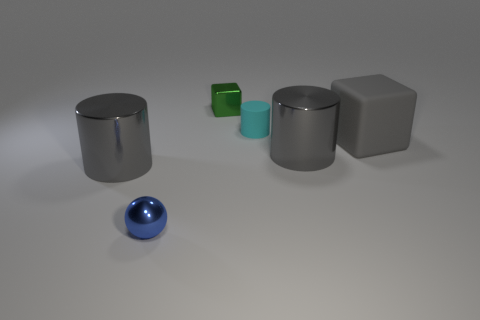Subtract all blue blocks. How many gray cylinders are left? 2 Subtract all tiny cyan cylinders. How many cylinders are left? 2 Add 1 small things. How many objects exist? 7 Subtract all cyan cylinders. How many cylinders are left? 2 Subtract all blocks. How many objects are left? 4 Subtract all blue cylinders. Subtract all purple spheres. How many cylinders are left? 3 Add 1 cyan matte cylinders. How many cyan matte cylinders are left? 2 Add 4 tiny brown cylinders. How many tiny brown cylinders exist? 4 Subtract 0 brown cubes. How many objects are left? 6 Subtract all brown shiny objects. Subtract all small metal objects. How many objects are left? 4 